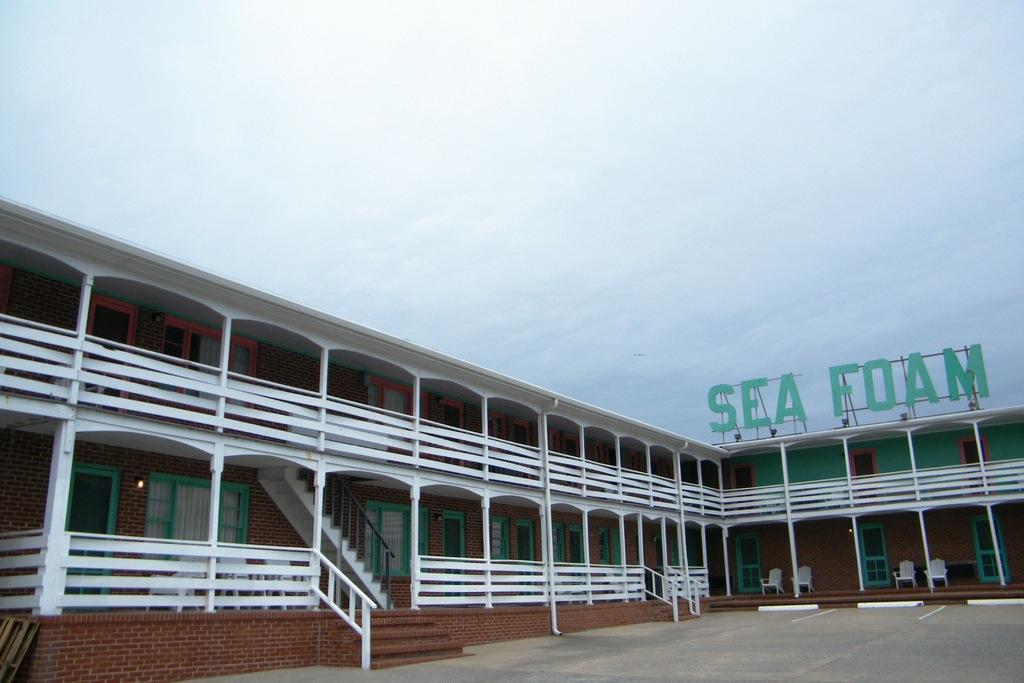What type of structure is visible in the image? There is a building in the image. Where are the chairs located in the image? The chairs are in the bottom right of the image. What can be seen at the top of the image? There is a sky at the top of the image. What type of pan can be seen being used to cook food in the image? There is no pan or cooking activity present in the image. Can you hear any sounds coming from the building in the image? The image is silent, and we cannot hear any sounds from the building or any other source. 